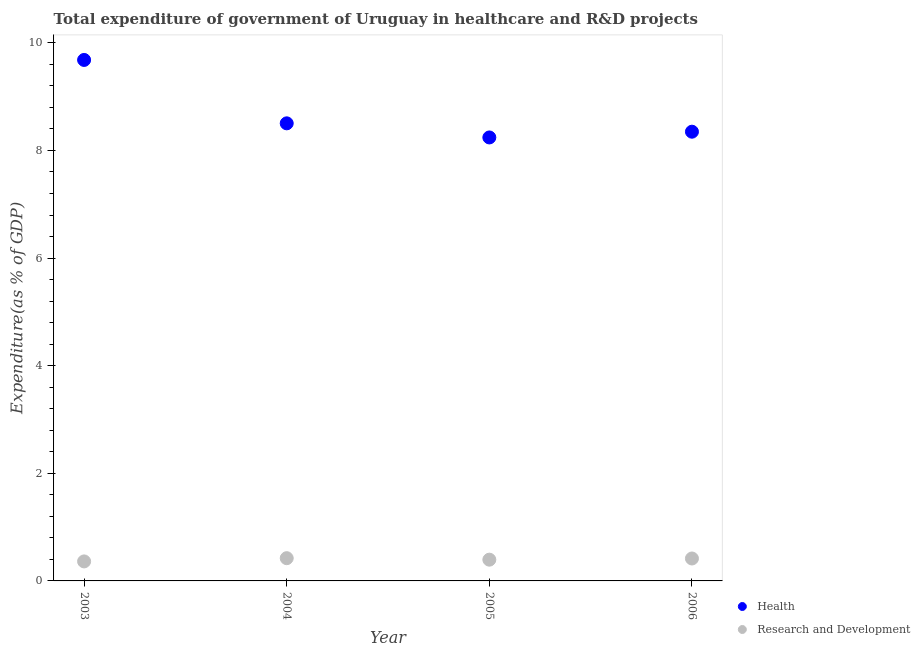How many different coloured dotlines are there?
Your answer should be compact. 2. Is the number of dotlines equal to the number of legend labels?
Offer a terse response. Yes. What is the expenditure in healthcare in 2006?
Provide a succinct answer. 8.35. Across all years, what is the maximum expenditure in r&d?
Offer a very short reply. 0.42. Across all years, what is the minimum expenditure in healthcare?
Give a very brief answer. 8.24. In which year was the expenditure in r&d minimum?
Your answer should be compact. 2003. What is the total expenditure in healthcare in the graph?
Offer a terse response. 34.78. What is the difference between the expenditure in healthcare in 2004 and that in 2005?
Provide a succinct answer. 0.26. What is the difference between the expenditure in r&d in 2003 and the expenditure in healthcare in 2005?
Keep it short and to the point. -7.88. What is the average expenditure in healthcare per year?
Provide a short and direct response. 8.69. In the year 2003, what is the difference between the expenditure in healthcare and expenditure in r&d?
Your response must be concise. 9.32. In how many years, is the expenditure in healthcare greater than 0.4 %?
Provide a succinct answer. 4. What is the ratio of the expenditure in r&d in 2005 to that in 2006?
Provide a succinct answer. 0.95. Is the difference between the expenditure in healthcare in 2005 and 2006 greater than the difference between the expenditure in r&d in 2005 and 2006?
Offer a very short reply. No. What is the difference between the highest and the second highest expenditure in healthcare?
Provide a succinct answer. 1.18. What is the difference between the highest and the lowest expenditure in r&d?
Provide a succinct answer. 0.06. Does the expenditure in healthcare monotonically increase over the years?
Make the answer very short. No. How many dotlines are there?
Provide a short and direct response. 2. How many years are there in the graph?
Your answer should be very brief. 4. What is the difference between two consecutive major ticks on the Y-axis?
Ensure brevity in your answer.  2. Are the values on the major ticks of Y-axis written in scientific E-notation?
Provide a succinct answer. No. Does the graph contain any zero values?
Give a very brief answer. No. Does the graph contain grids?
Your answer should be compact. No. Where does the legend appear in the graph?
Give a very brief answer. Bottom right. How many legend labels are there?
Offer a very short reply. 2. How are the legend labels stacked?
Your answer should be very brief. Vertical. What is the title of the graph?
Your answer should be compact. Total expenditure of government of Uruguay in healthcare and R&D projects. Does "Net National savings" appear as one of the legend labels in the graph?
Keep it short and to the point. No. What is the label or title of the X-axis?
Provide a succinct answer. Year. What is the label or title of the Y-axis?
Provide a short and direct response. Expenditure(as % of GDP). What is the Expenditure(as % of GDP) of Health in 2003?
Provide a succinct answer. 9.68. What is the Expenditure(as % of GDP) in Research and Development in 2003?
Provide a succinct answer. 0.36. What is the Expenditure(as % of GDP) in Health in 2004?
Offer a very short reply. 8.5. What is the Expenditure(as % of GDP) of Research and Development in 2004?
Make the answer very short. 0.42. What is the Expenditure(as % of GDP) of Health in 2005?
Your response must be concise. 8.24. What is the Expenditure(as % of GDP) of Research and Development in 2005?
Give a very brief answer. 0.4. What is the Expenditure(as % of GDP) of Health in 2006?
Provide a succinct answer. 8.35. What is the Expenditure(as % of GDP) of Research and Development in 2006?
Ensure brevity in your answer.  0.42. Across all years, what is the maximum Expenditure(as % of GDP) of Health?
Make the answer very short. 9.68. Across all years, what is the maximum Expenditure(as % of GDP) of Research and Development?
Provide a short and direct response. 0.42. Across all years, what is the minimum Expenditure(as % of GDP) of Health?
Offer a terse response. 8.24. Across all years, what is the minimum Expenditure(as % of GDP) of Research and Development?
Your answer should be very brief. 0.36. What is the total Expenditure(as % of GDP) of Health in the graph?
Your response must be concise. 34.78. What is the total Expenditure(as % of GDP) of Research and Development in the graph?
Provide a succinct answer. 1.6. What is the difference between the Expenditure(as % of GDP) of Health in 2003 and that in 2004?
Your response must be concise. 1.18. What is the difference between the Expenditure(as % of GDP) in Research and Development in 2003 and that in 2004?
Offer a terse response. -0.06. What is the difference between the Expenditure(as % of GDP) in Health in 2003 and that in 2005?
Your answer should be very brief. 1.44. What is the difference between the Expenditure(as % of GDP) of Research and Development in 2003 and that in 2005?
Your answer should be compact. -0.03. What is the difference between the Expenditure(as % of GDP) in Health in 2003 and that in 2006?
Offer a terse response. 1.33. What is the difference between the Expenditure(as % of GDP) of Research and Development in 2003 and that in 2006?
Ensure brevity in your answer.  -0.05. What is the difference between the Expenditure(as % of GDP) of Health in 2004 and that in 2005?
Provide a short and direct response. 0.26. What is the difference between the Expenditure(as % of GDP) of Research and Development in 2004 and that in 2005?
Provide a succinct answer. 0.03. What is the difference between the Expenditure(as % of GDP) in Health in 2004 and that in 2006?
Make the answer very short. 0.16. What is the difference between the Expenditure(as % of GDP) in Research and Development in 2004 and that in 2006?
Give a very brief answer. 0.01. What is the difference between the Expenditure(as % of GDP) in Health in 2005 and that in 2006?
Make the answer very short. -0.11. What is the difference between the Expenditure(as % of GDP) of Research and Development in 2005 and that in 2006?
Provide a succinct answer. -0.02. What is the difference between the Expenditure(as % of GDP) in Health in 2003 and the Expenditure(as % of GDP) in Research and Development in 2004?
Give a very brief answer. 9.26. What is the difference between the Expenditure(as % of GDP) of Health in 2003 and the Expenditure(as % of GDP) of Research and Development in 2005?
Keep it short and to the point. 9.29. What is the difference between the Expenditure(as % of GDP) of Health in 2003 and the Expenditure(as % of GDP) of Research and Development in 2006?
Make the answer very short. 9.27. What is the difference between the Expenditure(as % of GDP) of Health in 2004 and the Expenditure(as % of GDP) of Research and Development in 2005?
Provide a short and direct response. 8.11. What is the difference between the Expenditure(as % of GDP) of Health in 2004 and the Expenditure(as % of GDP) of Research and Development in 2006?
Your answer should be very brief. 8.09. What is the difference between the Expenditure(as % of GDP) in Health in 2005 and the Expenditure(as % of GDP) in Research and Development in 2006?
Your response must be concise. 7.83. What is the average Expenditure(as % of GDP) of Health per year?
Give a very brief answer. 8.69. What is the average Expenditure(as % of GDP) of Research and Development per year?
Your response must be concise. 0.4. In the year 2003, what is the difference between the Expenditure(as % of GDP) of Health and Expenditure(as % of GDP) of Research and Development?
Make the answer very short. 9.32. In the year 2004, what is the difference between the Expenditure(as % of GDP) in Health and Expenditure(as % of GDP) in Research and Development?
Your answer should be very brief. 8.08. In the year 2005, what is the difference between the Expenditure(as % of GDP) of Health and Expenditure(as % of GDP) of Research and Development?
Provide a short and direct response. 7.85. In the year 2006, what is the difference between the Expenditure(as % of GDP) of Health and Expenditure(as % of GDP) of Research and Development?
Your answer should be very brief. 7.93. What is the ratio of the Expenditure(as % of GDP) in Health in 2003 to that in 2004?
Provide a short and direct response. 1.14. What is the ratio of the Expenditure(as % of GDP) of Research and Development in 2003 to that in 2004?
Offer a very short reply. 0.86. What is the ratio of the Expenditure(as % of GDP) of Health in 2003 to that in 2005?
Make the answer very short. 1.17. What is the ratio of the Expenditure(as % of GDP) of Research and Development in 2003 to that in 2005?
Your answer should be very brief. 0.92. What is the ratio of the Expenditure(as % of GDP) of Health in 2003 to that in 2006?
Ensure brevity in your answer.  1.16. What is the ratio of the Expenditure(as % of GDP) in Research and Development in 2003 to that in 2006?
Give a very brief answer. 0.87. What is the ratio of the Expenditure(as % of GDP) of Health in 2004 to that in 2005?
Give a very brief answer. 1.03. What is the ratio of the Expenditure(as % of GDP) of Research and Development in 2004 to that in 2005?
Offer a terse response. 1.07. What is the ratio of the Expenditure(as % of GDP) in Health in 2004 to that in 2006?
Provide a succinct answer. 1.02. What is the ratio of the Expenditure(as % of GDP) in Research and Development in 2004 to that in 2006?
Your answer should be compact. 1.01. What is the ratio of the Expenditure(as % of GDP) in Health in 2005 to that in 2006?
Your answer should be compact. 0.99. What is the ratio of the Expenditure(as % of GDP) of Research and Development in 2005 to that in 2006?
Make the answer very short. 0.95. What is the difference between the highest and the second highest Expenditure(as % of GDP) of Health?
Offer a very short reply. 1.18. What is the difference between the highest and the second highest Expenditure(as % of GDP) in Research and Development?
Provide a succinct answer. 0.01. What is the difference between the highest and the lowest Expenditure(as % of GDP) of Health?
Offer a very short reply. 1.44. What is the difference between the highest and the lowest Expenditure(as % of GDP) of Research and Development?
Make the answer very short. 0.06. 